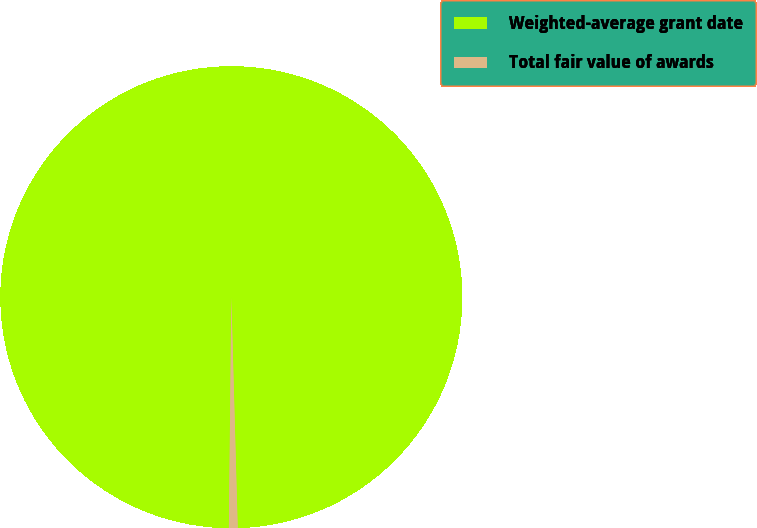Convert chart. <chart><loc_0><loc_0><loc_500><loc_500><pie_chart><fcel>Weighted-average grant date<fcel>Total fair value of awards<nl><fcel>99.39%<fcel>0.61%<nl></chart> 